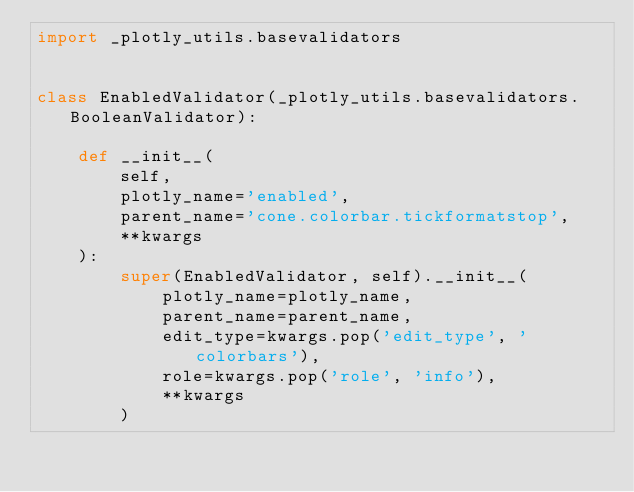Convert code to text. <code><loc_0><loc_0><loc_500><loc_500><_Python_>import _plotly_utils.basevalidators


class EnabledValidator(_plotly_utils.basevalidators.BooleanValidator):

    def __init__(
        self,
        plotly_name='enabled',
        parent_name='cone.colorbar.tickformatstop',
        **kwargs
    ):
        super(EnabledValidator, self).__init__(
            plotly_name=plotly_name,
            parent_name=parent_name,
            edit_type=kwargs.pop('edit_type', 'colorbars'),
            role=kwargs.pop('role', 'info'),
            **kwargs
        )
</code> 